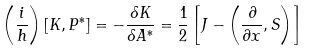<formula> <loc_0><loc_0><loc_500><loc_500>\left ( \frac { i } { h } \right ) \left [ K , P ^ { * } \right ] = - \frac { \delta K } { \delta A ^ { * } } = \frac { 1 } { 2 } \left [ J - \left ( \frac { \partial } { \partial x } , S \right ) \right ]</formula> 